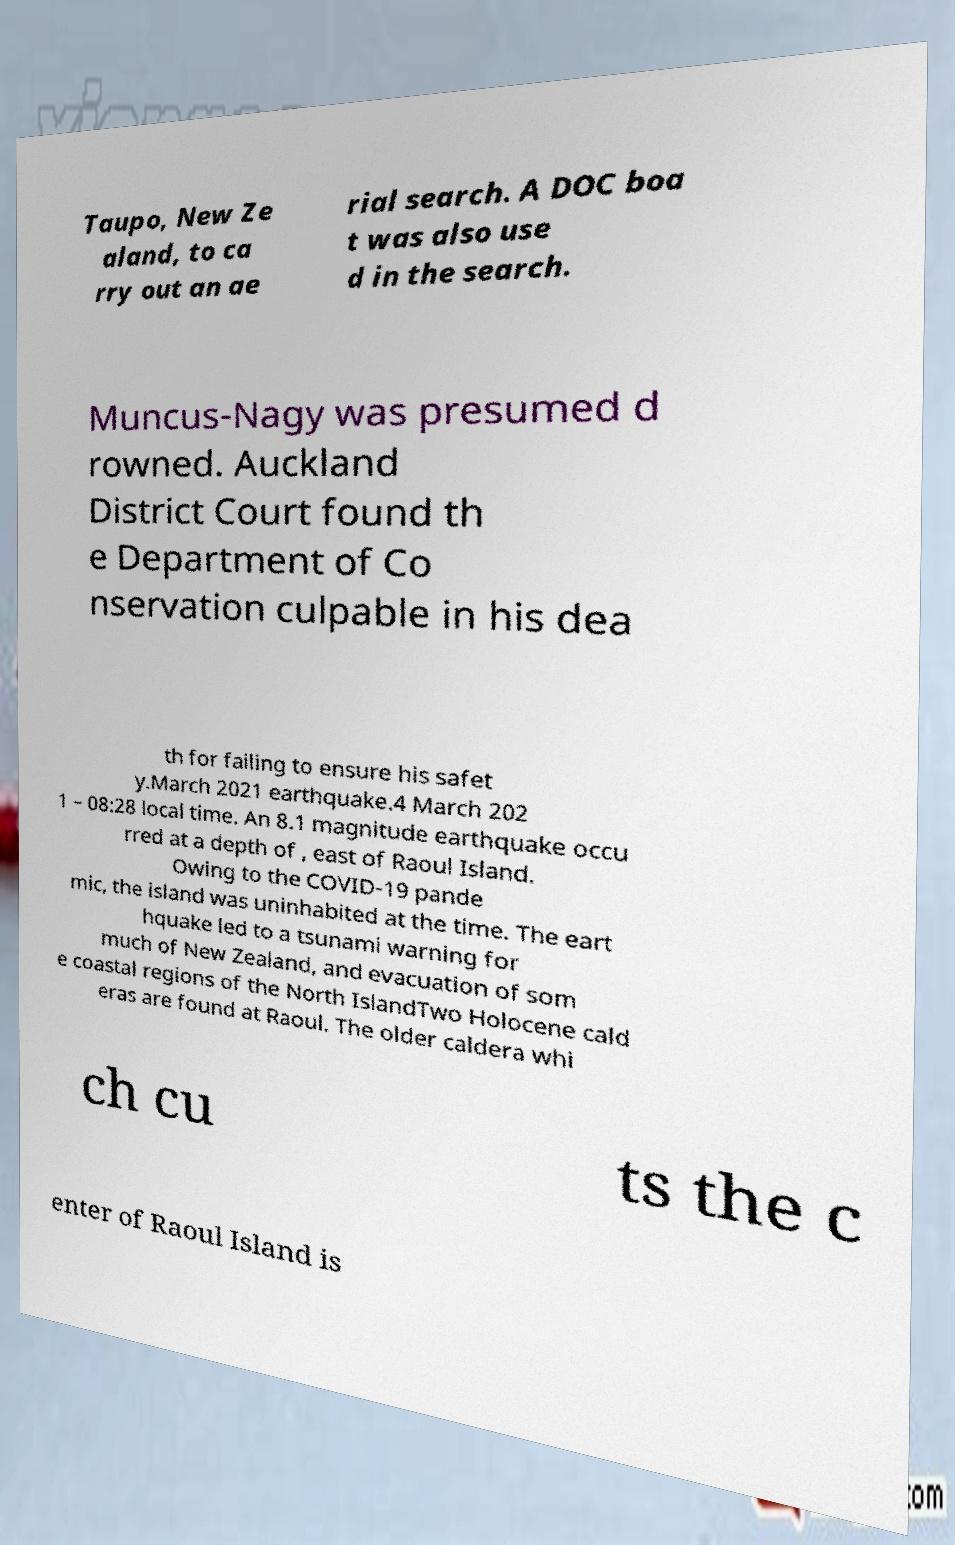I need the written content from this picture converted into text. Can you do that? Taupo, New Ze aland, to ca rry out an ae rial search. A DOC boa t was also use d in the search. Muncus-Nagy was presumed d rowned. Auckland District Court found th e Department of Co nservation culpable in his dea th for failing to ensure his safet y.March 2021 earthquake.4 March 202 1 – 08:28 local time. An 8.1 magnitude earthquake occu rred at a depth of , east of Raoul Island. Owing to the COVID-19 pande mic, the island was uninhabited at the time. The eart hquake led to a tsunami warning for much of New Zealand, and evacuation of som e coastal regions of the North IslandTwo Holocene cald eras are found at Raoul. The older caldera whi ch cu ts the c enter of Raoul Island is 